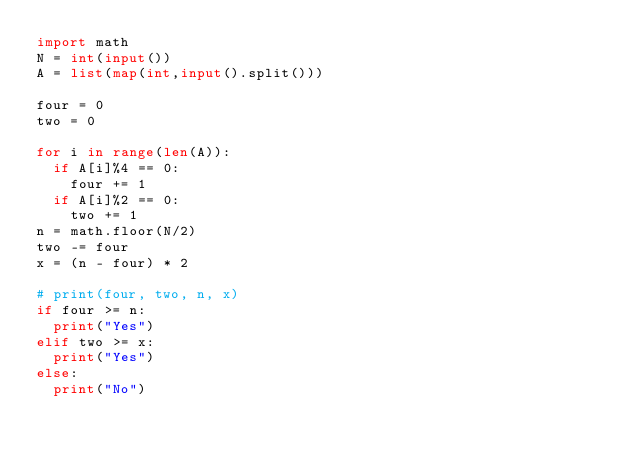Convert code to text. <code><loc_0><loc_0><loc_500><loc_500><_Python_>import math
N = int(input())
A = list(map(int,input().split()))

four = 0
two = 0

for i in range(len(A)):
  if A[i]%4 == 0:
    four += 1
  if A[i]%2 == 0:
    two += 1
n = math.floor(N/2)
two -= four
x = (n - four) * 2

# print(four, two, n, x)
if four >= n:
  print("Yes")
elif two >= x:
  print("Yes")
else:
  print("No")
</code> 